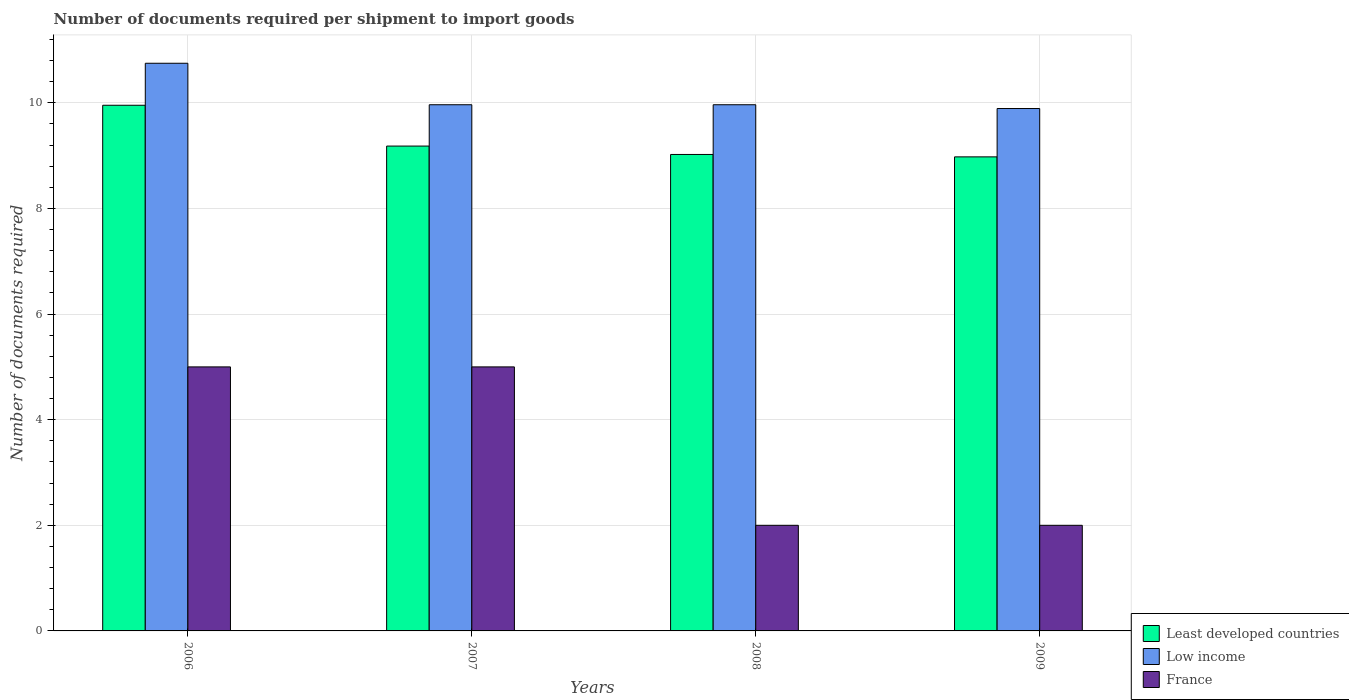How many different coloured bars are there?
Offer a very short reply. 3. How many groups of bars are there?
Ensure brevity in your answer.  4. Are the number of bars per tick equal to the number of legend labels?
Provide a succinct answer. Yes. How many bars are there on the 3rd tick from the right?
Offer a very short reply. 3. What is the label of the 1st group of bars from the left?
Offer a very short reply. 2006. What is the number of documents required per shipment to import goods in France in 2009?
Offer a terse response. 2. Across all years, what is the maximum number of documents required per shipment to import goods in Least developed countries?
Keep it short and to the point. 9.95. Across all years, what is the minimum number of documents required per shipment to import goods in Low income?
Your answer should be compact. 9.89. What is the total number of documents required per shipment to import goods in France in the graph?
Offer a very short reply. 14. What is the difference between the number of documents required per shipment to import goods in Low income in 2006 and that in 2007?
Your answer should be very brief. 0.79. What is the difference between the number of documents required per shipment to import goods in Least developed countries in 2007 and the number of documents required per shipment to import goods in Low income in 2006?
Ensure brevity in your answer.  -1.57. What is the average number of documents required per shipment to import goods in Low income per year?
Your response must be concise. 10.14. In the year 2007, what is the difference between the number of documents required per shipment to import goods in Low income and number of documents required per shipment to import goods in France?
Your answer should be compact. 4.96. Is the difference between the number of documents required per shipment to import goods in Low income in 2007 and 2009 greater than the difference between the number of documents required per shipment to import goods in France in 2007 and 2009?
Provide a succinct answer. No. What is the difference between the highest and the second highest number of documents required per shipment to import goods in Least developed countries?
Provide a succinct answer. 0.77. What is the difference between the highest and the lowest number of documents required per shipment to import goods in Least developed countries?
Your answer should be compact. 0.98. In how many years, is the number of documents required per shipment to import goods in France greater than the average number of documents required per shipment to import goods in France taken over all years?
Your response must be concise. 2. Is the sum of the number of documents required per shipment to import goods in France in 2006 and 2009 greater than the maximum number of documents required per shipment to import goods in Least developed countries across all years?
Ensure brevity in your answer.  No. What does the 1st bar from the left in 2006 represents?
Make the answer very short. Least developed countries. What does the 1st bar from the right in 2008 represents?
Make the answer very short. France. Is it the case that in every year, the sum of the number of documents required per shipment to import goods in France and number of documents required per shipment to import goods in Low income is greater than the number of documents required per shipment to import goods in Least developed countries?
Offer a terse response. Yes. What is the difference between two consecutive major ticks on the Y-axis?
Provide a short and direct response. 2. Are the values on the major ticks of Y-axis written in scientific E-notation?
Make the answer very short. No. Does the graph contain any zero values?
Make the answer very short. No. What is the title of the graph?
Your answer should be very brief. Number of documents required per shipment to import goods. Does "Cayman Islands" appear as one of the legend labels in the graph?
Your answer should be very brief. No. What is the label or title of the X-axis?
Offer a very short reply. Years. What is the label or title of the Y-axis?
Make the answer very short. Number of documents required. What is the Number of documents required in Least developed countries in 2006?
Keep it short and to the point. 9.95. What is the Number of documents required in Low income in 2006?
Offer a terse response. 10.75. What is the Number of documents required of France in 2006?
Provide a short and direct response. 5. What is the Number of documents required in Least developed countries in 2007?
Ensure brevity in your answer.  9.18. What is the Number of documents required in Low income in 2007?
Your answer should be compact. 9.96. What is the Number of documents required of Least developed countries in 2008?
Offer a very short reply. 9.02. What is the Number of documents required in Low income in 2008?
Make the answer very short. 9.96. What is the Number of documents required of Least developed countries in 2009?
Provide a short and direct response. 8.98. What is the Number of documents required of Low income in 2009?
Provide a succinct answer. 9.89. Across all years, what is the maximum Number of documents required of Least developed countries?
Give a very brief answer. 9.95. Across all years, what is the maximum Number of documents required of Low income?
Your response must be concise. 10.75. Across all years, what is the maximum Number of documents required in France?
Give a very brief answer. 5. Across all years, what is the minimum Number of documents required in Least developed countries?
Your response must be concise. 8.98. Across all years, what is the minimum Number of documents required in Low income?
Provide a short and direct response. 9.89. What is the total Number of documents required of Least developed countries in the graph?
Keep it short and to the point. 37.14. What is the total Number of documents required of Low income in the graph?
Your response must be concise. 40.57. What is the total Number of documents required in France in the graph?
Ensure brevity in your answer.  14. What is the difference between the Number of documents required of Least developed countries in 2006 and that in 2007?
Offer a terse response. 0.77. What is the difference between the Number of documents required of Low income in 2006 and that in 2007?
Keep it short and to the point. 0.79. What is the difference between the Number of documents required in France in 2006 and that in 2007?
Your answer should be very brief. 0. What is the difference between the Number of documents required in Least developed countries in 2006 and that in 2008?
Your answer should be compact. 0.93. What is the difference between the Number of documents required in Low income in 2006 and that in 2008?
Give a very brief answer. 0.79. What is the difference between the Number of documents required of Least developed countries in 2006 and that in 2009?
Make the answer very short. 0.98. What is the difference between the Number of documents required in Low income in 2006 and that in 2009?
Ensure brevity in your answer.  0.86. What is the difference between the Number of documents required in Least developed countries in 2007 and that in 2008?
Your answer should be very brief. 0.16. What is the difference between the Number of documents required of Low income in 2007 and that in 2008?
Your answer should be very brief. 0. What is the difference between the Number of documents required of France in 2007 and that in 2008?
Offer a very short reply. 3. What is the difference between the Number of documents required in Least developed countries in 2007 and that in 2009?
Keep it short and to the point. 0.2. What is the difference between the Number of documents required in Low income in 2007 and that in 2009?
Your answer should be very brief. 0.07. What is the difference between the Number of documents required in Least developed countries in 2008 and that in 2009?
Provide a succinct answer. 0.05. What is the difference between the Number of documents required in Low income in 2008 and that in 2009?
Give a very brief answer. 0.07. What is the difference between the Number of documents required in France in 2008 and that in 2009?
Offer a terse response. 0. What is the difference between the Number of documents required of Least developed countries in 2006 and the Number of documents required of Low income in 2007?
Provide a succinct answer. -0.01. What is the difference between the Number of documents required of Least developed countries in 2006 and the Number of documents required of France in 2007?
Offer a terse response. 4.95. What is the difference between the Number of documents required in Low income in 2006 and the Number of documents required in France in 2007?
Provide a short and direct response. 5.75. What is the difference between the Number of documents required in Least developed countries in 2006 and the Number of documents required in Low income in 2008?
Your answer should be very brief. -0.01. What is the difference between the Number of documents required in Least developed countries in 2006 and the Number of documents required in France in 2008?
Your answer should be very brief. 7.95. What is the difference between the Number of documents required of Low income in 2006 and the Number of documents required of France in 2008?
Make the answer very short. 8.75. What is the difference between the Number of documents required of Least developed countries in 2006 and the Number of documents required of Low income in 2009?
Your answer should be compact. 0.06. What is the difference between the Number of documents required in Least developed countries in 2006 and the Number of documents required in France in 2009?
Make the answer very short. 7.95. What is the difference between the Number of documents required of Low income in 2006 and the Number of documents required of France in 2009?
Your answer should be very brief. 8.75. What is the difference between the Number of documents required in Least developed countries in 2007 and the Number of documents required in Low income in 2008?
Ensure brevity in your answer.  -0.78. What is the difference between the Number of documents required in Least developed countries in 2007 and the Number of documents required in France in 2008?
Your answer should be very brief. 7.18. What is the difference between the Number of documents required in Low income in 2007 and the Number of documents required in France in 2008?
Give a very brief answer. 7.96. What is the difference between the Number of documents required of Least developed countries in 2007 and the Number of documents required of Low income in 2009?
Provide a short and direct response. -0.71. What is the difference between the Number of documents required of Least developed countries in 2007 and the Number of documents required of France in 2009?
Give a very brief answer. 7.18. What is the difference between the Number of documents required of Low income in 2007 and the Number of documents required of France in 2009?
Offer a very short reply. 7.96. What is the difference between the Number of documents required in Least developed countries in 2008 and the Number of documents required in Low income in 2009?
Offer a terse response. -0.87. What is the difference between the Number of documents required in Least developed countries in 2008 and the Number of documents required in France in 2009?
Provide a succinct answer. 7.02. What is the difference between the Number of documents required of Low income in 2008 and the Number of documents required of France in 2009?
Your answer should be very brief. 7.96. What is the average Number of documents required of Least developed countries per year?
Ensure brevity in your answer.  9.28. What is the average Number of documents required in Low income per year?
Your response must be concise. 10.14. What is the average Number of documents required in France per year?
Make the answer very short. 3.5. In the year 2006, what is the difference between the Number of documents required of Least developed countries and Number of documents required of Low income?
Offer a terse response. -0.8. In the year 2006, what is the difference between the Number of documents required of Least developed countries and Number of documents required of France?
Provide a succinct answer. 4.95. In the year 2006, what is the difference between the Number of documents required of Low income and Number of documents required of France?
Keep it short and to the point. 5.75. In the year 2007, what is the difference between the Number of documents required in Least developed countries and Number of documents required in Low income?
Your answer should be very brief. -0.78. In the year 2007, what is the difference between the Number of documents required in Least developed countries and Number of documents required in France?
Offer a very short reply. 4.18. In the year 2007, what is the difference between the Number of documents required of Low income and Number of documents required of France?
Provide a succinct answer. 4.96. In the year 2008, what is the difference between the Number of documents required of Least developed countries and Number of documents required of Low income?
Offer a very short reply. -0.94. In the year 2008, what is the difference between the Number of documents required of Least developed countries and Number of documents required of France?
Your response must be concise. 7.02. In the year 2008, what is the difference between the Number of documents required in Low income and Number of documents required in France?
Provide a short and direct response. 7.96. In the year 2009, what is the difference between the Number of documents required in Least developed countries and Number of documents required in Low income?
Your response must be concise. -0.92. In the year 2009, what is the difference between the Number of documents required of Least developed countries and Number of documents required of France?
Your answer should be very brief. 6.98. In the year 2009, what is the difference between the Number of documents required of Low income and Number of documents required of France?
Ensure brevity in your answer.  7.89. What is the ratio of the Number of documents required in Least developed countries in 2006 to that in 2007?
Your answer should be compact. 1.08. What is the ratio of the Number of documents required in Low income in 2006 to that in 2007?
Your response must be concise. 1.08. What is the ratio of the Number of documents required in Least developed countries in 2006 to that in 2008?
Make the answer very short. 1.1. What is the ratio of the Number of documents required in Low income in 2006 to that in 2008?
Your answer should be compact. 1.08. What is the ratio of the Number of documents required of Least developed countries in 2006 to that in 2009?
Offer a very short reply. 1.11. What is the ratio of the Number of documents required in Low income in 2006 to that in 2009?
Your response must be concise. 1.09. What is the ratio of the Number of documents required in France in 2006 to that in 2009?
Offer a terse response. 2.5. What is the ratio of the Number of documents required of Least developed countries in 2007 to that in 2008?
Ensure brevity in your answer.  1.02. What is the ratio of the Number of documents required in Least developed countries in 2007 to that in 2009?
Offer a terse response. 1.02. What is the ratio of the Number of documents required in France in 2007 to that in 2009?
Ensure brevity in your answer.  2.5. What is the difference between the highest and the second highest Number of documents required of Least developed countries?
Your response must be concise. 0.77. What is the difference between the highest and the second highest Number of documents required of Low income?
Provide a succinct answer. 0.79. What is the difference between the highest and the second highest Number of documents required of France?
Offer a very short reply. 0. What is the difference between the highest and the lowest Number of documents required of Least developed countries?
Give a very brief answer. 0.98. What is the difference between the highest and the lowest Number of documents required of Low income?
Keep it short and to the point. 0.86. What is the difference between the highest and the lowest Number of documents required in France?
Ensure brevity in your answer.  3. 